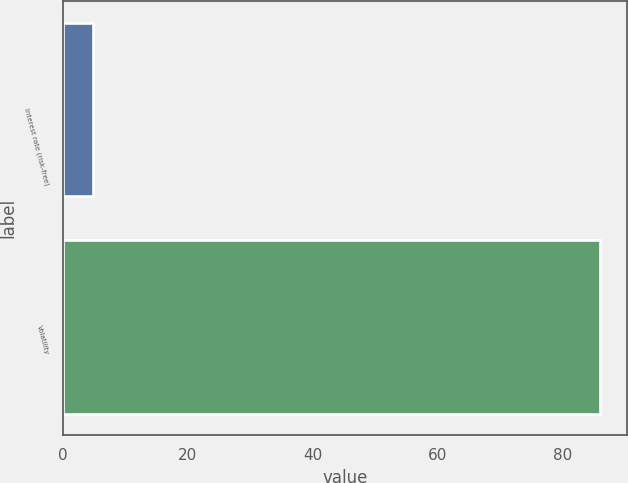<chart> <loc_0><loc_0><loc_500><loc_500><bar_chart><fcel>Interest rate (risk-free)<fcel>Volatility<nl><fcel>4.84<fcel>86<nl></chart> 